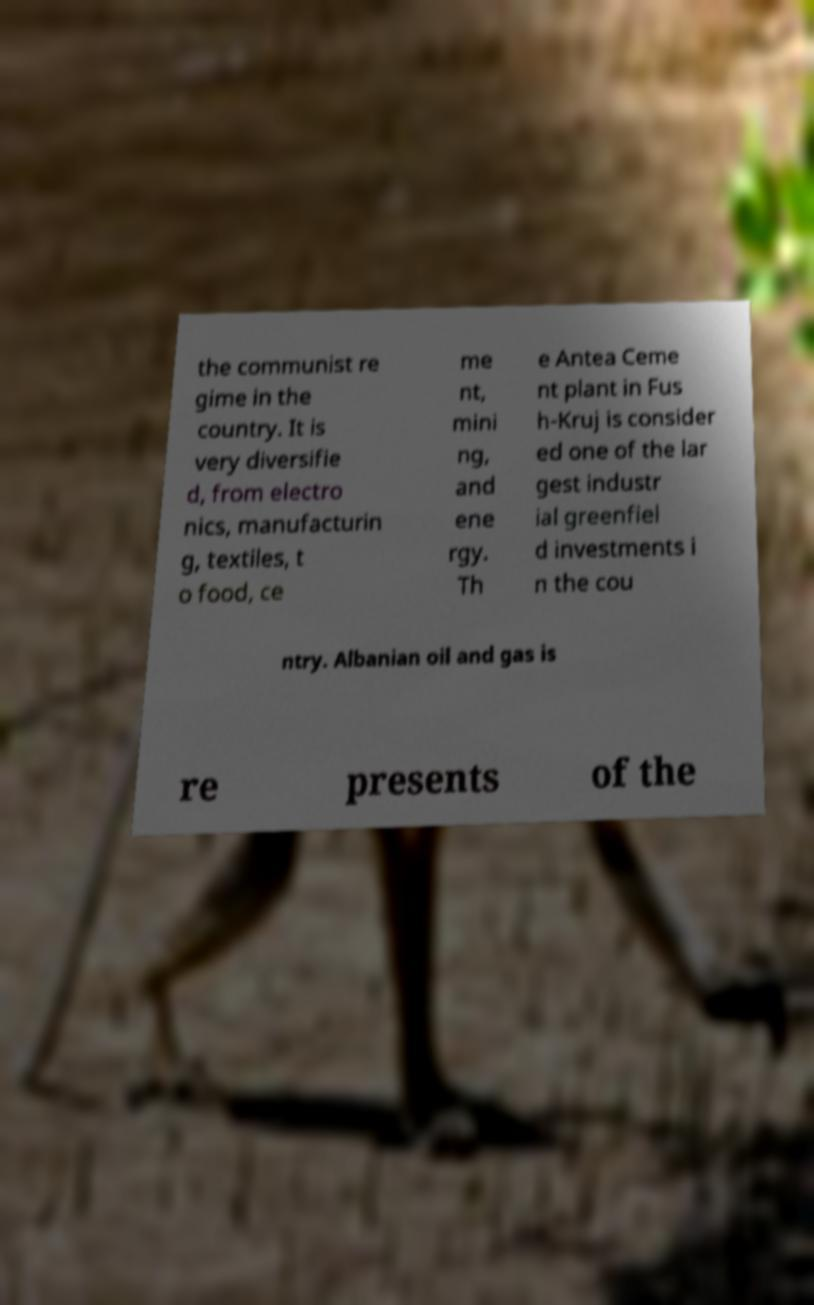Can you read and provide the text displayed in the image?This photo seems to have some interesting text. Can you extract and type it out for me? the communist re gime in the country. It is very diversifie d, from electro nics, manufacturin g, textiles, t o food, ce me nt, mini ng, and ene rgy. Th e Antea Ceme nt plant in Fus h-Kruj is consider ed one of the lar gest industr ial greenfiel d investments i n the cou ntry. Albanian oil and gas is re presents of the 